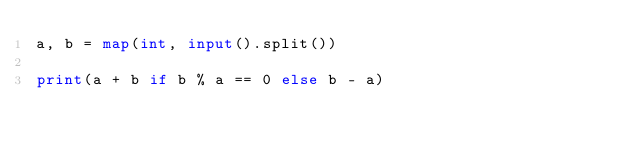<code> <loc_0><loc_0><loc_500><loc_500><_Python_>a, b = map(int, input().split())

print(a + b if b % a == 0 else b - a)
</code> 